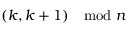<formula> <loc_0><loc_0><loc_500><loc_500>( k , k + 1 ) \mod n</formula> 